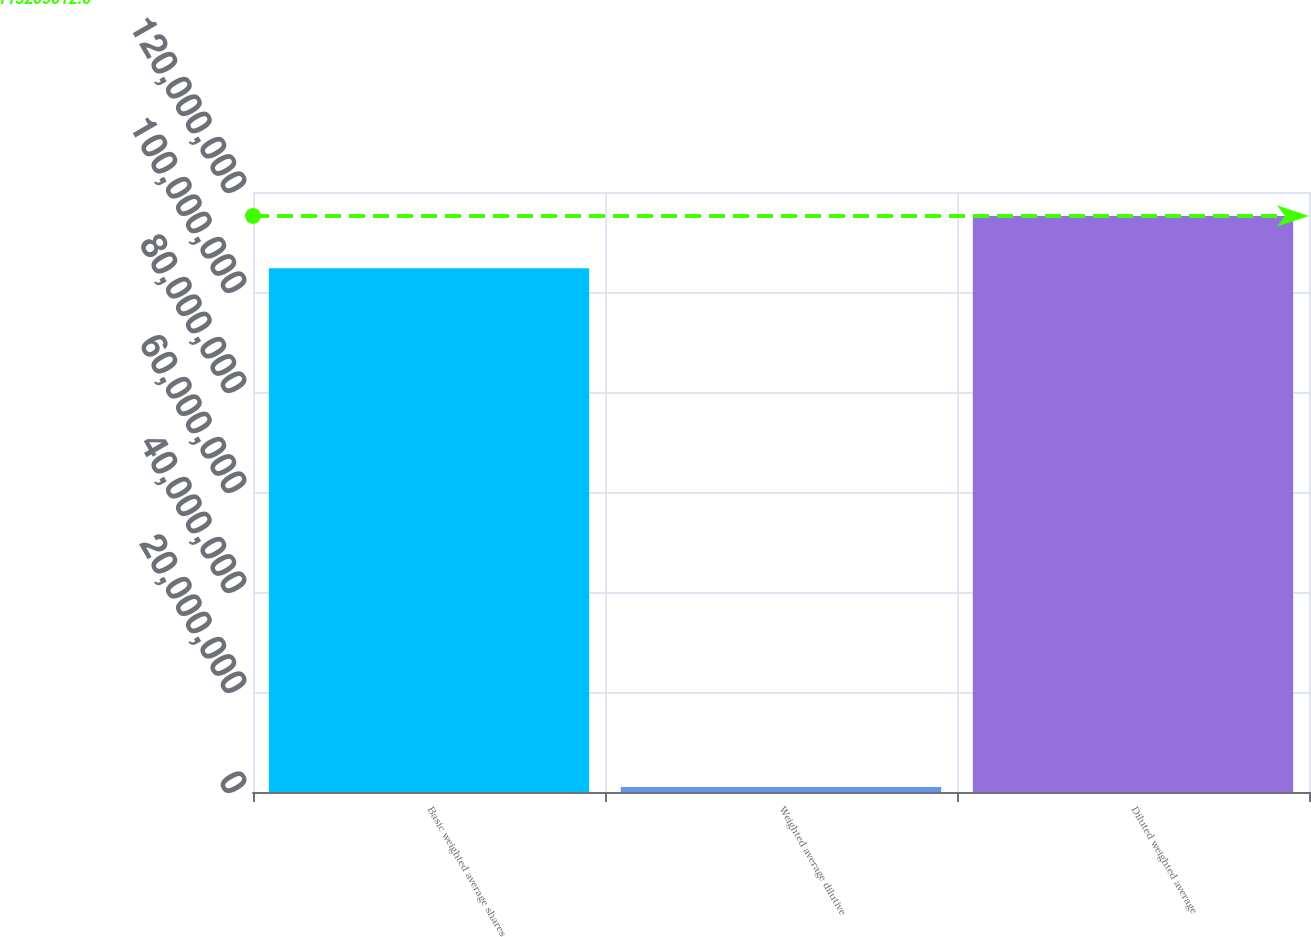Convert chart to OTSL. <chart><loc_0><loc_0><loc_500><loc_500><bar_chart><fcel>Basic weighted average shares<fcel>Weighted average dilutive<fcel>Diluted weighted average<nl><fcel>1.04735e+08<fcel>1.01595e+06<fcel>1.15209e+08<nl></chart> 